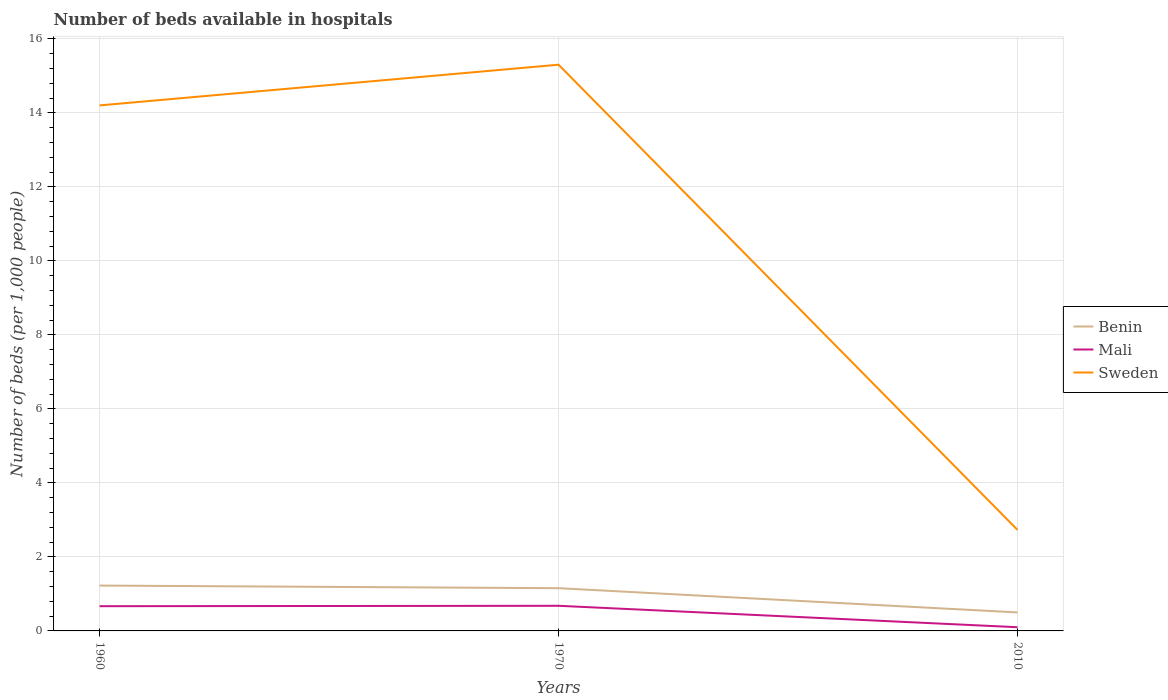How many different coloured lines are there?
Offer a very short reply. 3. Does the line corresponding to Mali intersect with the line corresponding to Sweden?
Ensure brevity in your answer.  No. Is the number of lines equal to the number of legend labels?
Your answer should be very brief. Yes. What is the total number of beds in the hospiatls of in Benin in the graph?
Ensure brevity in your answer.  0.73. What is the difference between the highest and the second highest number of beds in the hospiatls of in Mali?
Your answer should be very brief. 0.58. Is the number of beds in the hospiatls of in Benin strictly greater than the number of beds in the hospiatls of in Mali over the years?
Make the answer very short. No. How many lines are there?
Give a very brief answer. 3. What is the difference between two consecutive major ticks on the Y-axis?
Ensure brevity in your answer.  2. Does the graph contain any zero values?
Provide a short and direct response. No. Does the graph contain grids?
Your response must be concise. Yes. How many legend labels are there?
Provide a short and direct response. 3. How are the legend labels stacked?
Keep it short and to the point. Vertical. What is the title of the graph?
Provide a short and direct response. Number of beds available in hospitals. What is the label or title of the Y-axis?
Ensure brevity in your answer.  Number of beds (per 1,0 people). What is the Number of beds (per 1,000 people) of Benin in 1960?
Provide a succinct answer. 1.23. What is the Number of beds (per 1,000 people) of Mali in 1960?
Offer a terse response. 0.67. What is the Number of beds (per 1,000 people) in Sweden in 1960?
Your response must be concise. 14.2. What is the Number of beds (per 1,000 people) in Benin in 1970?
Provide a succinct answer. 1.15. What is the Number of beds (per 1,000 people) of Mali in 1970?
Your answer should be compact. 0.68. What is the Number of beds (per 1,000 people) of Sweden in 1970?
Provide a succinct answer. 15.3. What is the Number of beds (per 1,000 people) in Benin in 2010?
Offer a very short reply. 0.5. What is the Number of beds (per 1,000 people) of Mali in 2010?
Make the answer very short. 0.1. What is the Number of beds (per 1,000 people) of Sweden in 2010?
Keep it short and to the point. 2.73. Across all years, what is the maximum Number of beds (per 1,000 people) of Benin?
Offer a terse response. 1.23. Across all years, what is the maximum Number of beds (per 1,000 people) of Mali?
Your answer should be very brief. 0.68. Across all years, what is the maximum Number of beds (per 1,000 people) of Sweden?
Your answer should be compact. 15.3. Across all years, what is the minimum Number of beds (per 1,000 people) in Benin?
Offer a terse response. 0.5. Across all years, what is the minimum Number of beds (per 1,000 people) in Mali?
Provide a short and direct response. 0.1. Across all years, what is the minimum Number of beds (per 1,000 people) of Sweden?
Your answer should be compact. 2.73. What is the total Number of beds (per 1,000 people) of Benin in the graph?
Your answer should be very brief. 2.88. What is the total Number of beds (per 1,000 people) of Mali in the graph?
Provide a short and direct response. 1.45. What is the total Number of beds (per 1,000 people) in Sweden in the graph?
Ensure brevity in your answer.  32.23. What is the difference between the Number of beds (per 1,000 people) of Benin in 1960 and that in 1970?
Your answer should be compact. 0.07. What is the difference between the Number of beds (per 1,000 people) of Mali in 1960 and that in 1970?
Your answer should be very brief. -0.01. What is the difference between the Number of beds (per 1,000 people) of Sweden in 1960 and that in 1970?
Ensure brevity in your answer.  -1.1. What is the difference between the Number of beds (per 1,000 people) of Benin in 1960 and that in 2010?
Your response must be concise. 0.73. What is the difference between the Number of beds (per 1,000 people) of Mali in 1960 and that in 2010?
Keep it short and to the point. 0.57. What is the difference between the Number of beds (per 1,000 people) of Sweden in 1960 and that in 2010?
Provide a short and direct response. 11.47. What is the difference between the Number of beds (per 1,000 people) in Benin in 1970 and that in 2010?
Give a very brief answer. 0.65. What is the difference between the Number of beds (per 1,000 people) in Mali in 1970 and that in 2010?
Offer a terse response. 0.58. What is the difference between the Number of beds (per 1,000 people) in Sweden in 1970 and that in 2010?
Give a very brief answer. 12.57. What is the difference between the Number of beds (per 1,000 people) of Benin in 1960 and the Number of beds (per 1,000 people) of Mali in 1970?
Provide a short and direct response. 0.55. What is the difference between the Number of beds (per 1,000 people) of Benin in 1960 and the Number of beds (per 1,000 people) of Sweden in 1970?
Your answer should be very brief. -14.07. What is the difference between the Number of beds (per 1,000 people) of Mali in 1960 and the Number of beds (per 1,000 people) of Sweden in 1970?
Offer a very short reply. -14.63. What is the difference between the Number of beds (per 1,000 people) in Benin in 1960 and the Number of beds (per 1,000 people) in Mali in 2010?
Your response must be concise. 1.13. What is the difference between the Number of beds (per 1,000 people) in Benin in 1960 and the Number of beds (per 1,000 people) in Sweden in 2010?
Your response must be concise. -1.5. What is the difference between the Number of beds (per 1,000 people) in Mali in 1960 and the Number of beds (per 1,000 people) in Sweden in 2010?
Keep it short and to the point. -2.06. What is the difference between the Number of beds (per 1,000 people) in Benin in 1970 and the Number of beds (per 1,000 people) in Mali in 2010?
Ensure brevity in your answer.  1.05. What is the difference between the Number of beds (per 1,000 people) of Benin in 1970 and the Number of beds (per 1,000 people) of Sweden in 2010?
Make the answer very short. -1.58. What is the difference between the Number of beds (per 1,000 people) of Mali in 1970 and the Number of beds (per 1,000 people) of Sweden in 2010?
Make the answer very short. -2.05. What is the average Number of beds (per 1,000 people) of Benin per year?
Provide a short and direct response. 0.96. What is the average Number of beds (per 1,000 people) in Mali per year?
Your response must be concise. 0.48. What is the average Number of beds (per 1,000 people) in Sweden per year?
Give a very brief answer. 10.74. In the year 1960, what is the difference between the Number of beds (per 1,000 people) of Benin and Number of beds (per 1,000 people) of Mali?
Offer a terse response. 0.56. In the year 1960, what is the difference between the Number of beds (per 1,000 people) in Benin and Number of beds (per 1,000 people) in Sweden?
Ensure brevity in your answer.  -12.97. In the year 1960, what is the difference between the Number of beds (per 1,000 people) in Mali and Number of beds (per 1,000 people) in Sweden?
Your answer should be compact. -13.53. In the year 1970, what is the difference between the Number of beds (per 1,000 people) in Benin and Number of beds (per 1,000 people) in Mali?
Ensure brevity in your answer.  0.48. In the year 1970, what is the difference between the Number of beds (per 1,000 people) of Benin and Number of beds (per 1,000 people) of Sweden?
Offer a terse response. -14.15. In the year 1970, what is the difference between the Number of beds (per 1,000 people) of Mali and Number of beds (per 1,000 people) of Sweden?
Ensure brevity in your answer.  -14.62. In the year 2010, what is the difference between the Number of beds (per 1,000 people) of Benin and Number of beds (per 1,000 people) of Sweden?
Offer a very short reply. -2.23. In the year 2010, what is the difference between the Number of beds (per 1,000 people) of Mali and Number of beds (per 1,000 people) of Sweden?
Provide a short and direct response. -2.63. What is the ratio of the Number of beds (per 1,000 people) of Benin in 1960 to that in 1970?
Your response must be concise. 1.06. What is the ratio of the Number of beds (per 1,000 people) in Mali in 1960 to that in 1970?
Provide a succinct answer. 0.98. What is the ratio of the Number of beds (per 1,000 people) of Sweden in 1960 to that in 1970?
Ensure brevity in your answer.  0.93. What is the ratio of the Number of beds (per 1,000 people) in Benin in 1960 to that in 2010?
Provide a succinct answer. 2.45. What is the ratio of the Number of beds (per 1,000 people) of Mali in 1960 to that in 2010?
Your answer should be compact. 6.69. What is the ratio of the Number of beds (per 1,000 people) of Sweden in 1960 to that in 2010?
Give a very brief answer. 5.2. What is the ratio of the Number of beds (per 1,000 people) of Benin in 1970 to that in 2010?
Keep it short and to the point. 2.31. What is the ratio of the Number of beds (per 1,000 people) in Mali in 1970 to that in 2010?
Your answer should be very brief. 6.79. What is the ratio of the Number of beds (per 1,000 people) of Sweden in 1970 to that in 2010?
Make the answer very short. 5.6. What is the difference between the highest and the second highest Number of beds (per 1,000 people) of Benin?
Provide a succinct answer. 0.07. What is the difference between the highest and the second highest Number of beds (per 1,000 people) in Mali?
Give a very brief answer. 0.01. What is the difference between the highest and the second highest Number of beds (per 1,000 people) in Sweden?
Your answer should be compact. 1.1. What is the difference between the highest and the lowest Number of beds (per 1,000 people) of Benin?
Your response must be concise. 0.73. What is the difference between the highest and the lowest Number of beds (per 1,000 people) of Mali?
Offer a very short reply. 0.58. What is the difference between the highest and the lowest Number of beds (per 1,000 people) in Sweden?
Offer a very short reply. 12.57. 